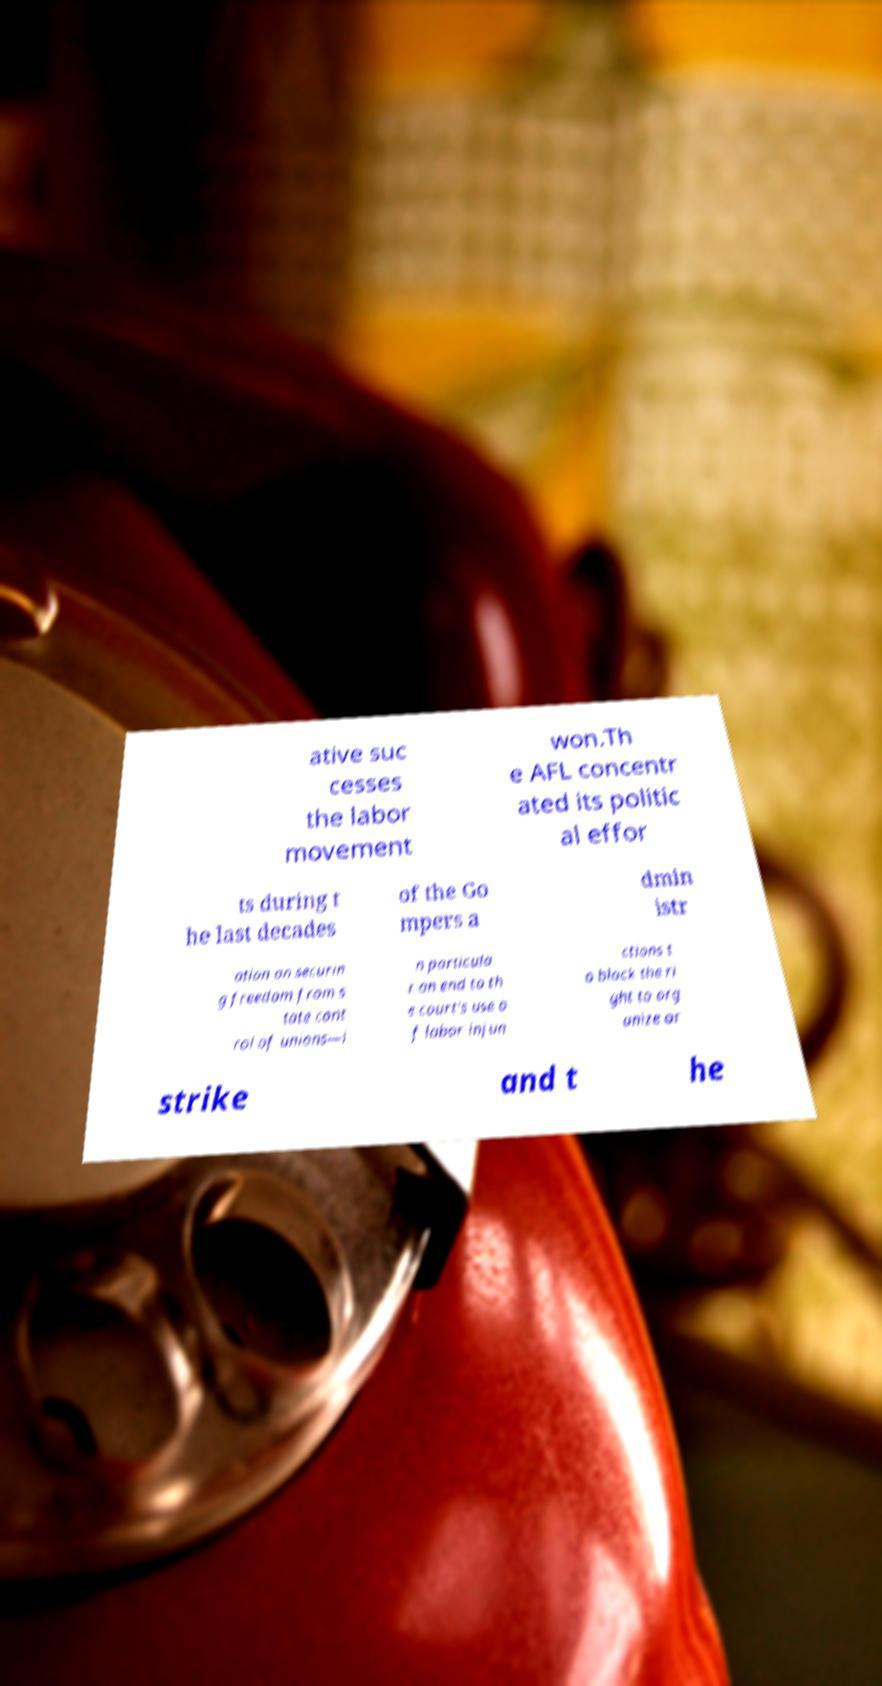Could you assist in decoding the text presented in this image and type it out clearly? ative suc cesses the labor movement won.Th e AFL concentr ated its politic al effor ts during t he last decades of the Go mpers a dmin istr ation on securin g freedom from s tate cont rol of unions—i n particula r an end to th e court's use o f labor injun ctions t o block the ri ght to org anize or strike and t he 